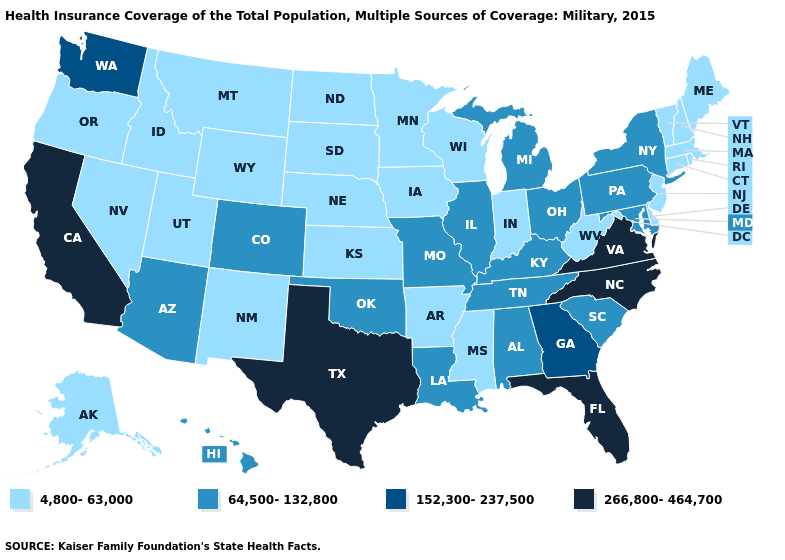What is the highest value in states that border New Hampshire?
Short answer required. 4,800-63,000. What is the value of Kentucky?
Keep it brief. 64,500-132,800. Does Illinois have the lowest value in the MidWest?
Write a very short answer. No. Which states have the highest value in the USA?
Short answer required. California, Florida, North Carolina, Texas, Virginia. Name the states that have a value in the range 4,800-63,000?
Be succinct. Alaska, Arkansas, Connecticut, Delaware, Idaho, Indiana, Iowa, Kansas, Maine, Massachusetts, Minnesota, Mississippi, Montana, Nebraska, Nevada, New Hampshire, New Jersey, New Mexico, North Dakota, Oregon, Rhode Island, South Dakota, Utah, Vermont, West Virginia, Wisconsin, Wyoming. What is the value of Arizona?
Answer briefly. 64,500-132,800. Among the states that border Louisiana , which have the lowest value?
Keep it brief. Arkansas, Mississippi. What is the value of New Hampshire?
Write a very short answer. 4,800-63,000. Does Maine have the highest value in the Northeast?
Concise answer only. No. What is the highest value in the USA?
Be succinct. 266,800-464,700. Name the states that have a value in the range 266,800-464,700?
Give a very brief answer. California, Florida, North Carolina, Texas, Virginia. What is the highest value in the West ?
Quick response, please. 266,800-464,700. Name the states that have a value in the range 4,800-63,000?
Write a very short answer. Alaska, Arkansas, Connecticut, Delaware, Idaho, Indiana, Iowa, Kansas, Maine, Massachusetts, Minnesota, Mississippi, Montana, Nebraska, Nevada, New Hampshire, New Jersey, New Mexico, North Dakota, Oregon, Rhode Island, South Dakota, Utah, Vermont, West Virginia, Wisconsin, Wyoming. 